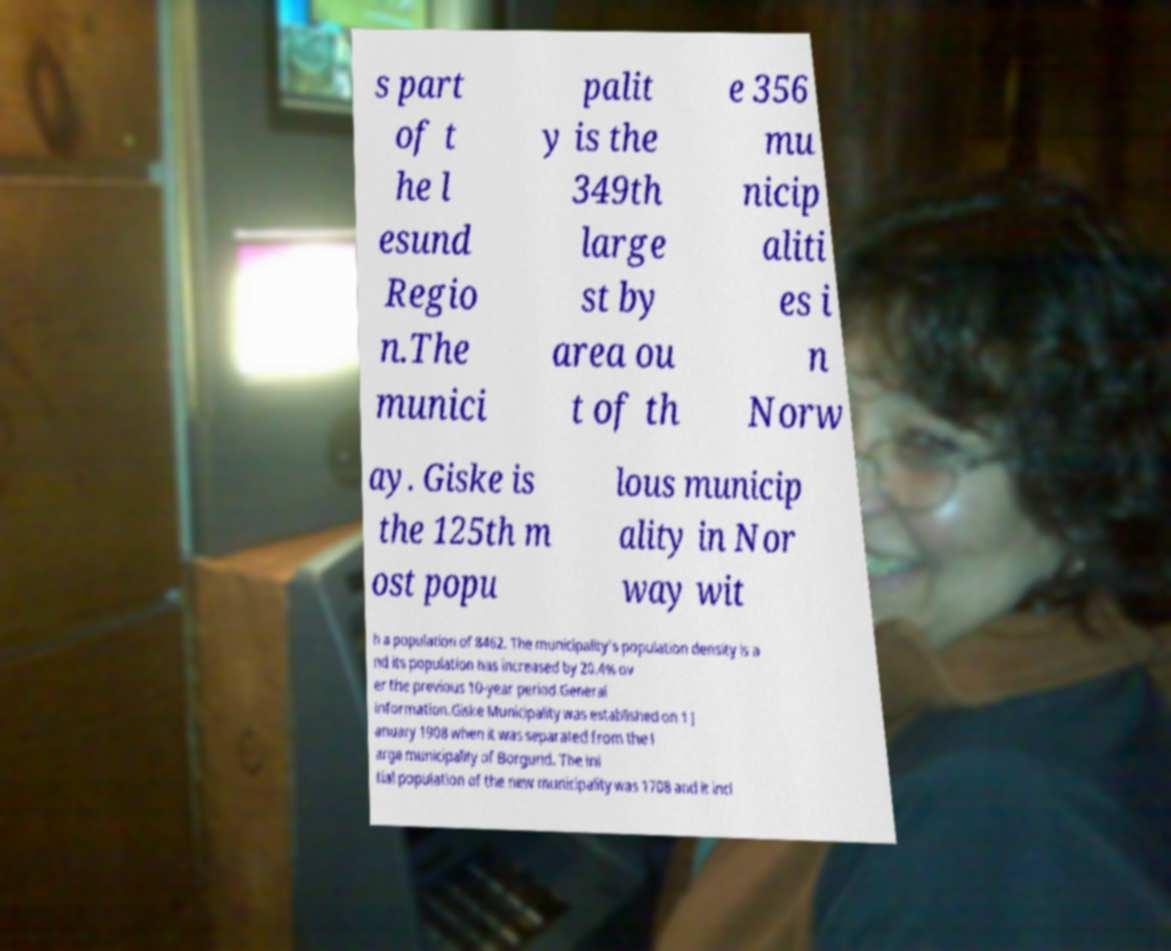Could you extract and type out the text from this image? s part of t he l esund Regio n.The munici palit y is the 349th large st by area ou t of th e 356 mu nicip aliti es i n Norw ay. Giske is the 125th m ost popu lous municip ality in Nor way wit h a population of 8462. The municipality's population density is a nd its population has increased by 20.4% ov er the previous 10-year period.General information.Giske Municipality was established on 1 J anuary 1908 when it was separated from the l arge municipality of Borgund. The ini tial population of the new municipality was 1708 and it incl 